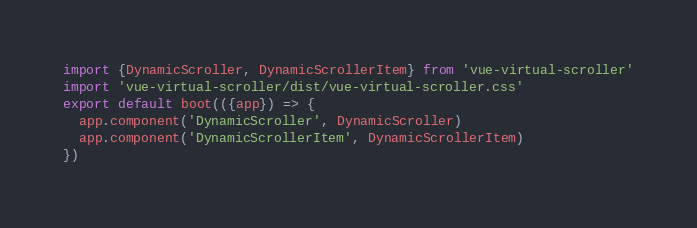<code> <loc_0><loc_0><loc_500><loc_500><_JavaScript_>import {DynamicScroller, DynamicScrollerItem} from 'vue-virtual-scroller'
import 'vue-virtual-scroller/dist/vue-virtual-scroller.css'
export default boot(({app}) => {
  app.component('DynamicScroller', DynamicScroller)
  app.component('DynamicScrollerItem', DynamicScrollerItem)
})
</code> 